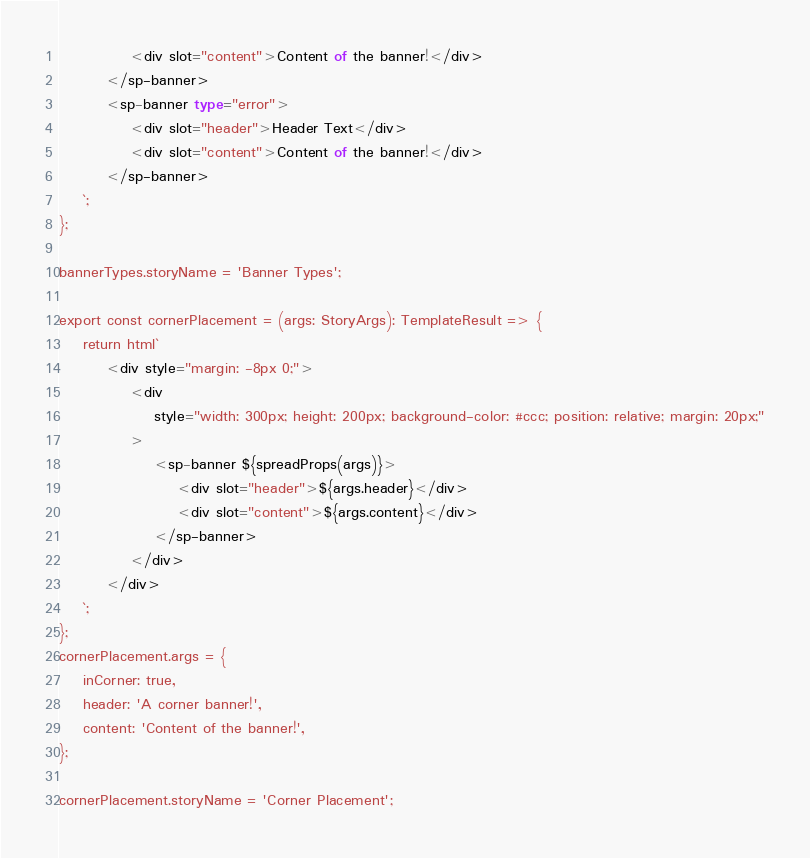<code> <loc_0><loc_0><loc_500><loc_500><_TypeScript_>            <div slot="content">Content of the banner!</div>
        </sp-banner>
        <sp-banner type="error">
            <div slot="header">Header Text</div>
            <div slot="content">Content of the banner!</div>
        </sp-banner>
    `;
};

bannerTypes.storyName = 'Banner Types';

export const cornerPlacement = (args: StoryArgs): TemplateResult => {
    return html`
        <div style="margin: -8px 0;">
            <div
                style="width: 300px; height: 200px; background-color: #ccc; position: relative; margin: 20px;"
            >
                <sp-banner ${spreadProps(args)}>
                    <div slot="header">${args.header}</div>
                    <div slot="content">${args.content}</div>
                </sp-banner>
            </div>
        </div>
    `;
};
cornerPlacement.args = {
    inCorner: true,
    header: 'A corner banner!',
    content: 'Content of the banner!',
};

cornerPlacement.storyName = 'Corner Placement';
</code> 